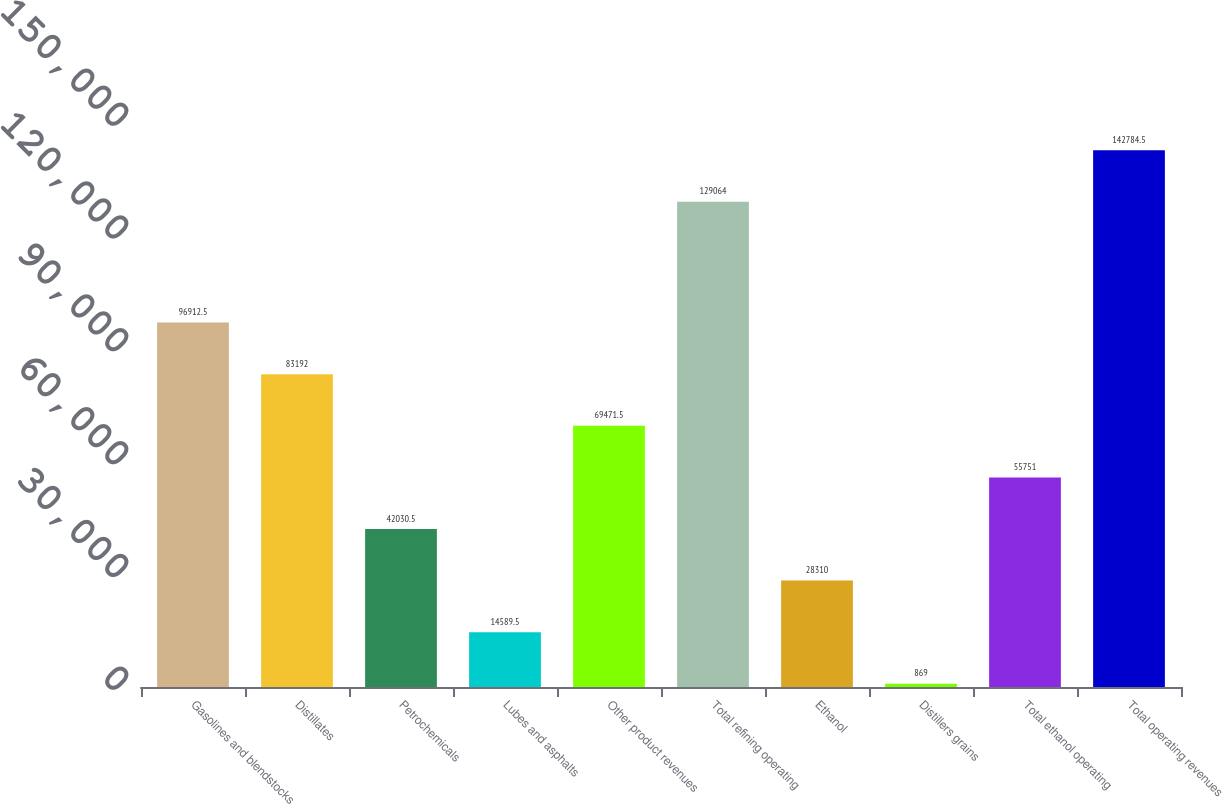<chart> <loc_0><loc_0><loc_500><loc_500><bar_chart><fcel>Gasolines and blendstocks<fcel>Distillates<fcel>Petrochemicals<fcel>Lubes and asphalts<fcel>Other product revenues<fcel>Total refining operating<fcel>Ethanol<fcel>Distillers grains<fcel>Total ethanol operating<fcel>Total operating revenues<nl><fcel>96912.5<fcel>83192<fcel>42030.5<fcel>14589.5<fcel>69471.5<fcel>129064<fcel>28310<fcel>869<fcel>55751<fcel>142784<nl></chart> 